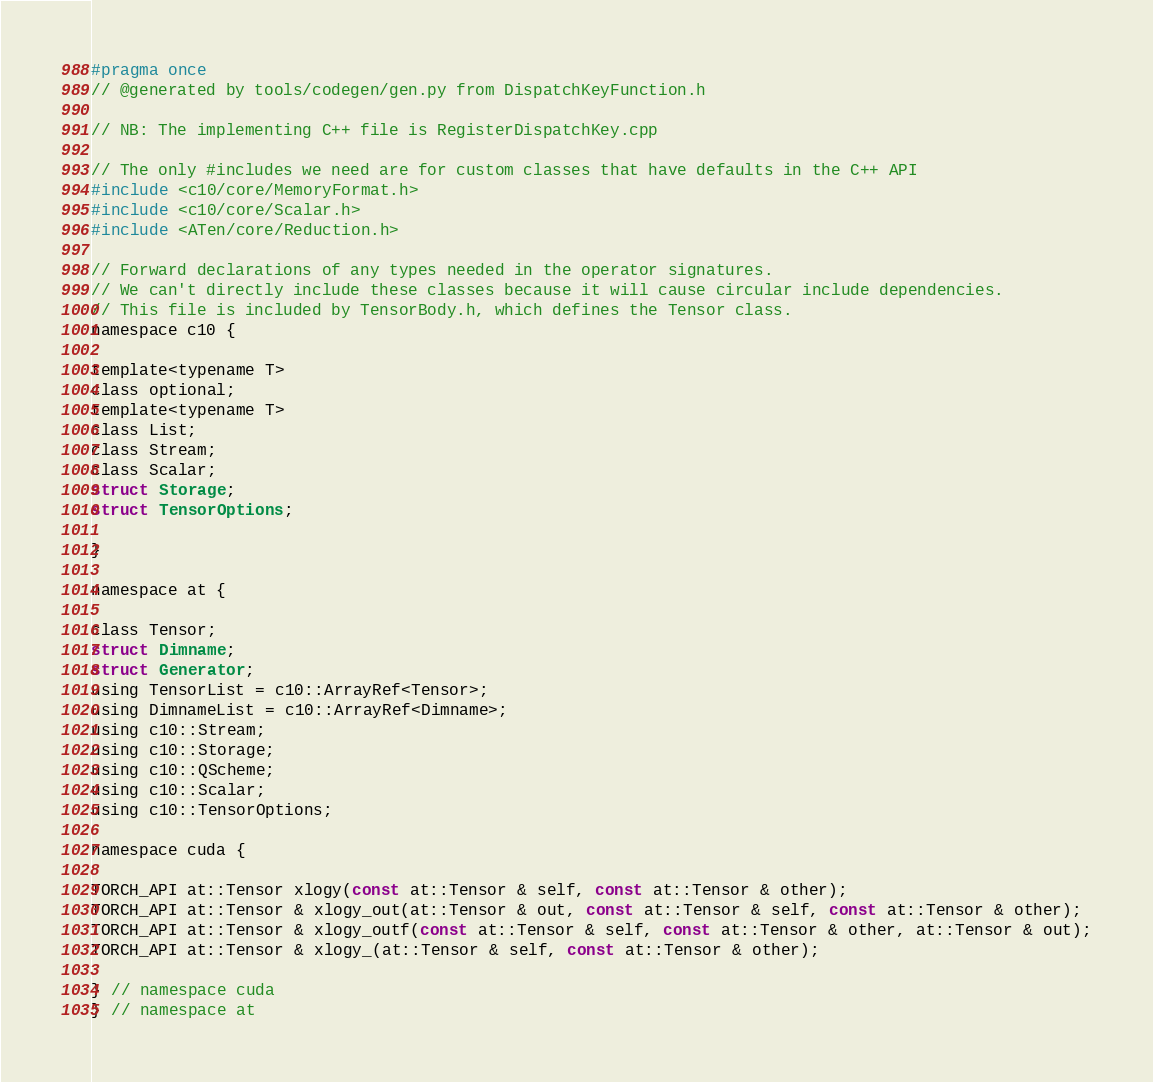<code> <loc_0><loc_0><loc_500><loc_500><_C_>#pragma once
// @generated by tools/codegen/gen.py from DispatchKeyFunction.h

// NB: The implementing C++ file is RegisterDispatchKey.cpp

// The only #includes we need are for custom classes that have defaults in the C++ API
#include <c10/core/MemoryFormat.h>
#include <c10/core/Scalar.h>
#include <ATen/core/Reduction.h>

// Forward declarations of any types needed in the operator signatures.
// We can't directly include these classes because it will cause circular include dependencies.
// This file is included by TensorBody.h, which defines the Tensor class.
namespace c10 {

template<typename T>
class optional;
template<typename T>
class List;
class Stream;
class Scalar;
struct Storage;
struct TensorOptions;

}

namespace at {

class Tensor;
struct Dimname;
struct Generator;
using TensorList = c10::ArrayRef<Tensor>;
using DimnameList = c10::ArrayRef<Dimname>;
using c10::Stream;
using c10::Storage;
using c10::QScheme;
using c10::Scalar;
using c10::TensorOptions;

namespace cuda {

TORCH_API at::Tensor xlogy(const at::Tensor & self, const at::Tensor & other);
TORCH_API at::Tensor & xlogy_out(at::Tensor & out, const at::Tensor & self, const at::Tensor & other);
TORCH_API at::Tensor & xlogy_outf(const at::Tensor & self, const at::Tensor & other, at::Tensor & out);
TORCH_API at::Tensor & xlogy_(at::Tensor & self, const at::Tensor & other);

} // namespace cuda
} // namespace at
</code> 